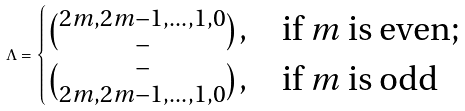<formula> <loc_0><loc_0><loc_500><loc_500>\Lambda = \begin{cases} \binom { 2 m , 2 m - 1 , \dots , 1 , 0 } { - } , & \text {if $m$ is even} ; \\ \binom { - } { 2 m , 2 m - 1 , \dots , 1 , 0 } , & \text {if $m$ is odd} \end{cases}</formula> 